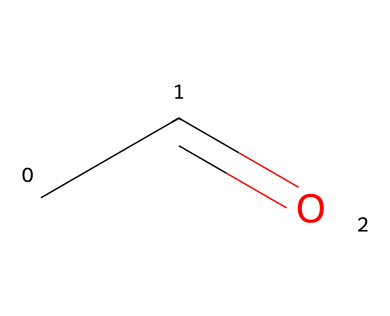What is the molecular formula of this compound? The SMILES representation CC=O indicates that there are two carbon atoms (C) and two hydrogen atoms (H), along with one oxygen atom (O). Thus, the molecular formula is deduced by counting each type of atom.
Answer: C2H4O How many carbon atoms are present in acetaldehyde? The SMILES representation CC=O shows two "C" letters, which signify two carbon atoms. Counting these directly from the structure confirms this information.
Answer: 2 What type of functional group is present in acetaldehyde? The structure CC=O indicates the presence of a carbonyl group (C=O). Since there is also a hydrogen atom connected to the carbon adjacent to the carbonyl, it identifies this compound specifically as an aldehyde.
Answer: aldehyde How many double bonds are in acetaldehyde? The SMILES representation CC=O has one double bond between the carbon and oxygen (C=O), which indicates that there is a double bond present in the chemical structure.
Answer: 1 What is the IUPAC name for CC=O? CC=O corresponds to the compound known as acetaldehyde, as per the naming conventions in organic chemistry, where aldehydes are named based on their longest carbon chain and functional group.
Answer: acetaldehyde Does acetaldehyde contain any nitrogen atoms? The SMILES representation CC=O has no 'N' symbol indicated in it, which means there are no nitrogen atoms present in the structure of acetaldehyde.
Answer: no 